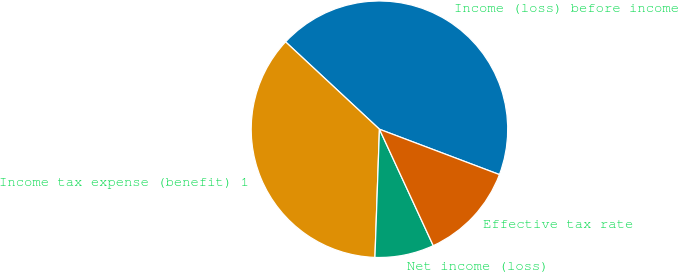Convert chart to OTSL. <chart><loc_0><loc_0><loc_500><loc_500><pie_chart><fcel>Income (loss) before income<fcel>Income tax expense (benefit) 1<fcel>Net income (loss)<fcel>Effective tax rate<nl><fcel>43.82%<fcel>36.37%<fcel>7.45%<fcel>12.36%<nl></chart> 